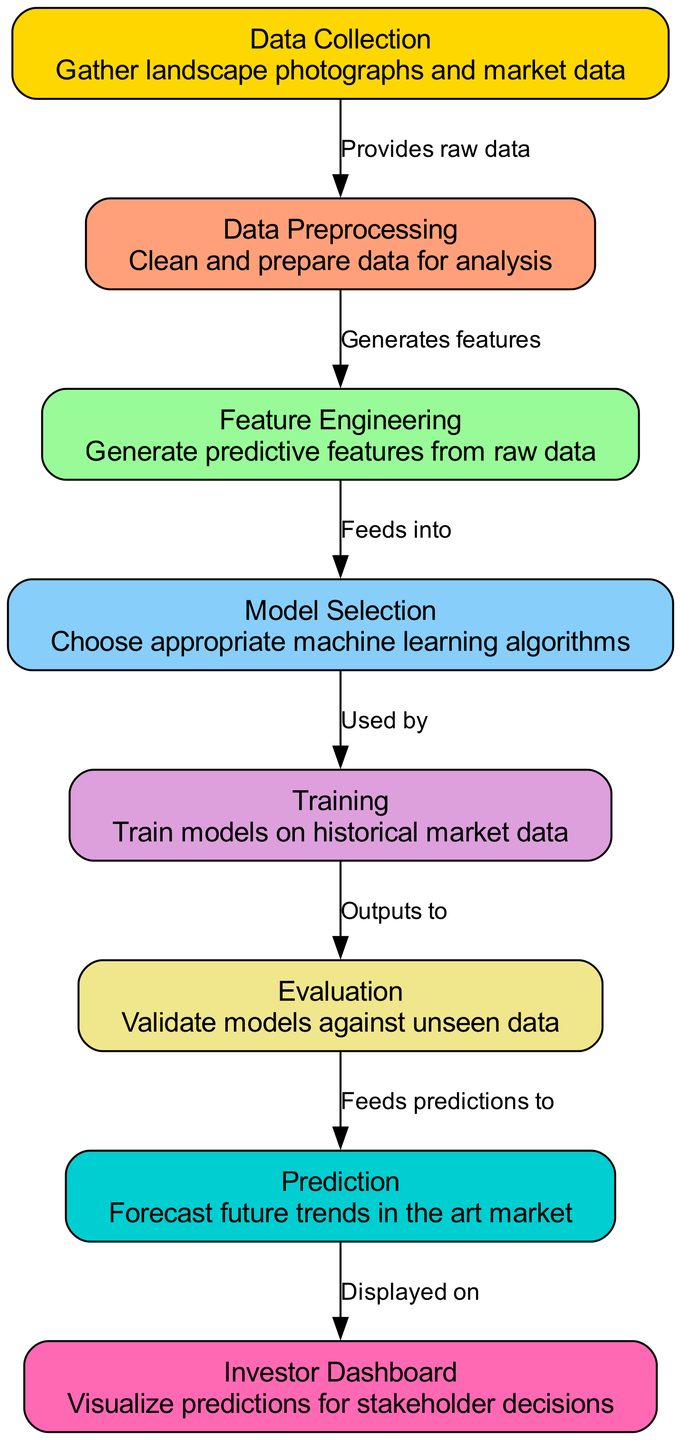What is the first node in the diagram? The first node in the diagram is labeled "Data Collection," which represents the initial step in the predictive analysis process.
Answer: Data Collection How many nodes are present in the diagram? There are a total of eight nodes in the diagram, each representing different steps in the predictive analysis process.
Answer: Eight What does the edge between "Training" and "Evaluation" signify? The edge indicates that the output of the "Training" step is fed into the "Evaluation" step, where models are validated against unseen data.
Answer: Outputs to Which node generates features from raw data? The node labeled "Feature Engineering" is responsible for generating predictive features from the cleaned and prepared data.
Answer: Feature Engineering What is the final output of the predictive analysis process? The final output of the predictive analysis process is displayed on the "Investor Dashboard," where predictions are visualized for stakeholder decisions.
Answer: Investor Dashboard What are the preceding steps before "Prediction"? The steps leading up to "Prediction" are "Evaluation," which validates models, and then "Prediction," which forecasts future trends based on the validated models.
Answer: Evaluation Identify the action performed by the "Model Selection" node. The "Model Selection" node is tasked with choosing appropriate machine learning algorithms to use for training predictive models.
Answer: Choose appropriate machine learning algorithms How does "Data Preprocessing" relate to "Data Collection"? "Data Preprocessing" follows "Data Collection," as it cleans and prepares the raw data gathered from the collection step for further analysis.
Answer: Provides raw data Which node directly feeds into "Prediction"? The node that directly feeds into "Prediction" is "Evaluation," which ensures that the models are validated before forecasting future trends.
Answer: Evaluation 